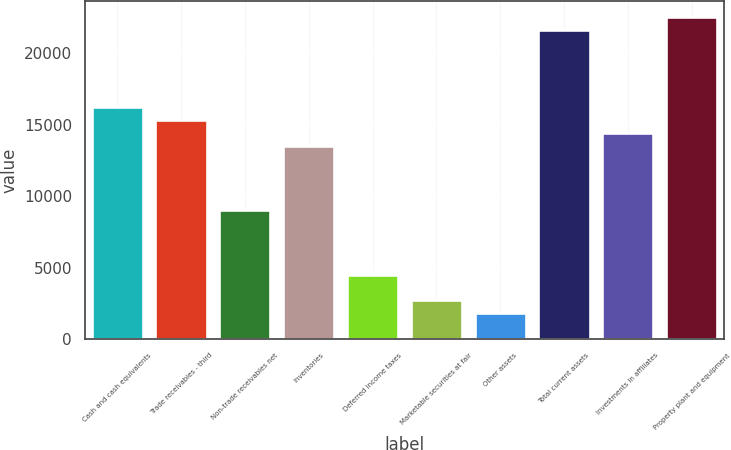Convert chart. <chart><loc_0><loc_0><loc_500><loc_500><bar_chart><fcel>Cash and cash equivalents<fcel>Trade receivables - third<fcel>Non-trade receivables net<fcel>Inventories<fcel>Deferred income taxes<fcel>Marketable securities at fair<fcel>Other assets<fcel>Total current assets<fcel>Investments in affiliates<fcel>Property plant and equipment<nl><fcel>16229.2<fcel>15327.8<fcel>9018<fcel>13525<fcel>4511<fcel>2708.2<fcel>1806.8<fcel>21637.6<fcel>14426.4<fcel>22539<nl></chart> 